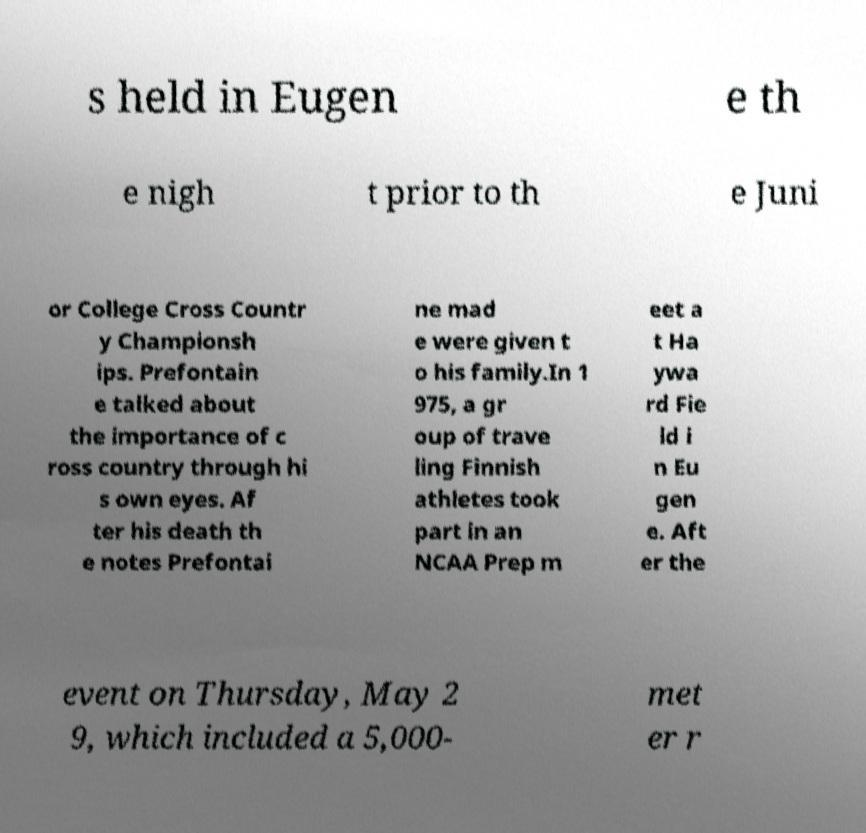For documentation purposes, I need the text within this image transcribed. Could you provide that? s held in Eugen e th e nigh t prior to th e Juni or College Cross Countr y Championsh ips. Prefontain e talked about the importance of c ross country through hi s own eyes. Af ter his death th e notes Prefontai ne mad e were given t o his family.In 1 975, a gr oup of trave ling Finnish athletes took part in an NCAA Prep m eet a t Ha ywa rd Fie ld i n Eu gen e. Aft er the event on Thursday, May 2 9, which included a 5,000- met er r 